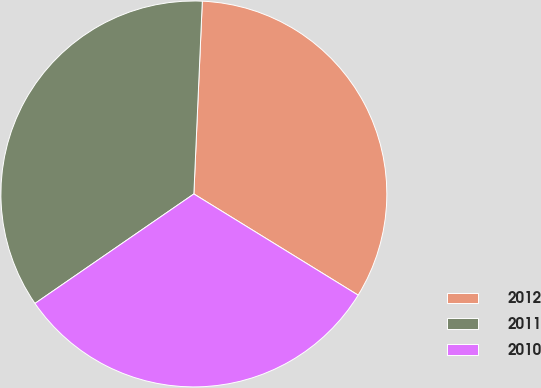<chart> <loc_0><loc_0><loc_500><loc_500><pie_chart><fcel>2012<fcel>2011<fcel>2010<nl><fcel>33.09%<fcel>35.3%<fcel>31.61%<nl></chart> 